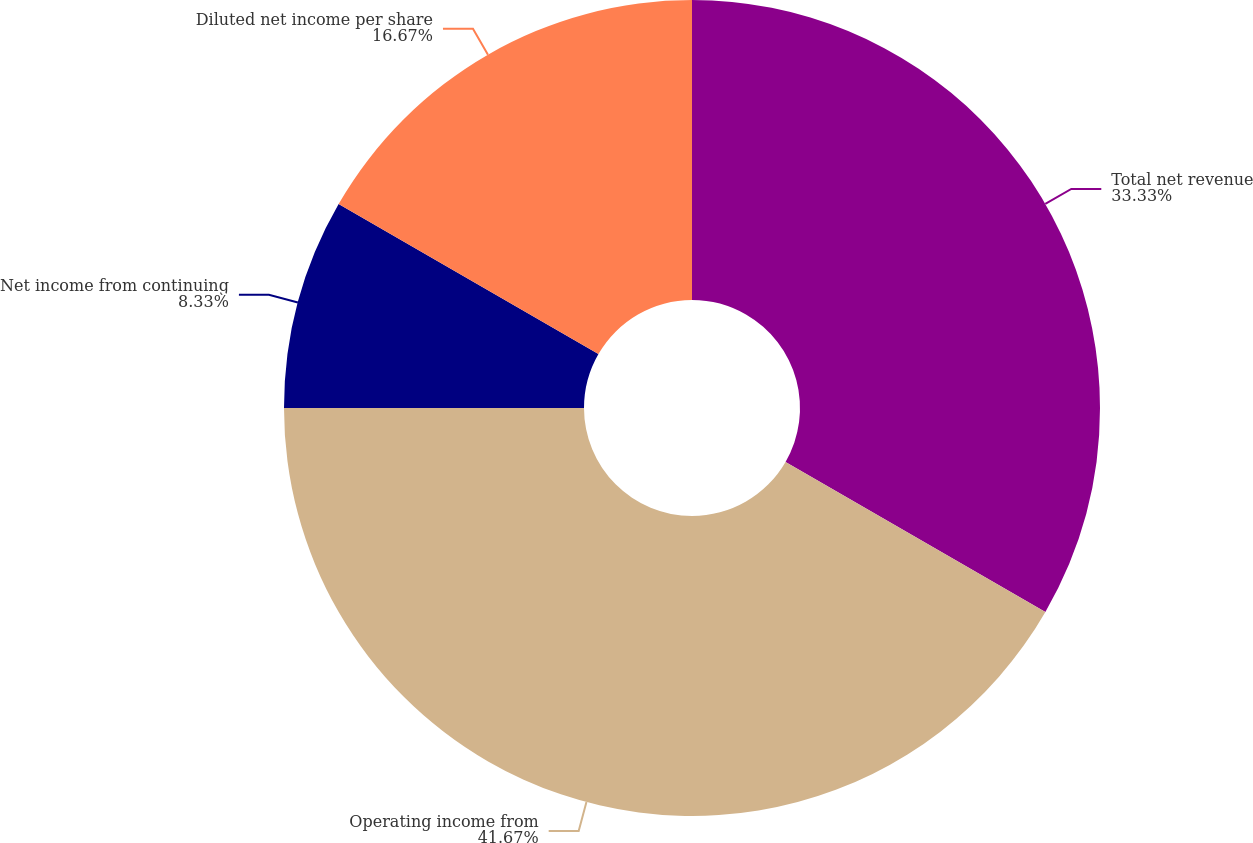Convert chart to OTSL. <chart><loc_0><loc_0><loc_500><loc_500><pie_chart><fcel>Total net revenue<fcel>Operating income from<fcel>Net income from continuing<fcel>Diluted net income per share<nl><fcel>33.33%<fcel>41.67%<fcel>8.33%<fcel>16.67%<nl></chart> 